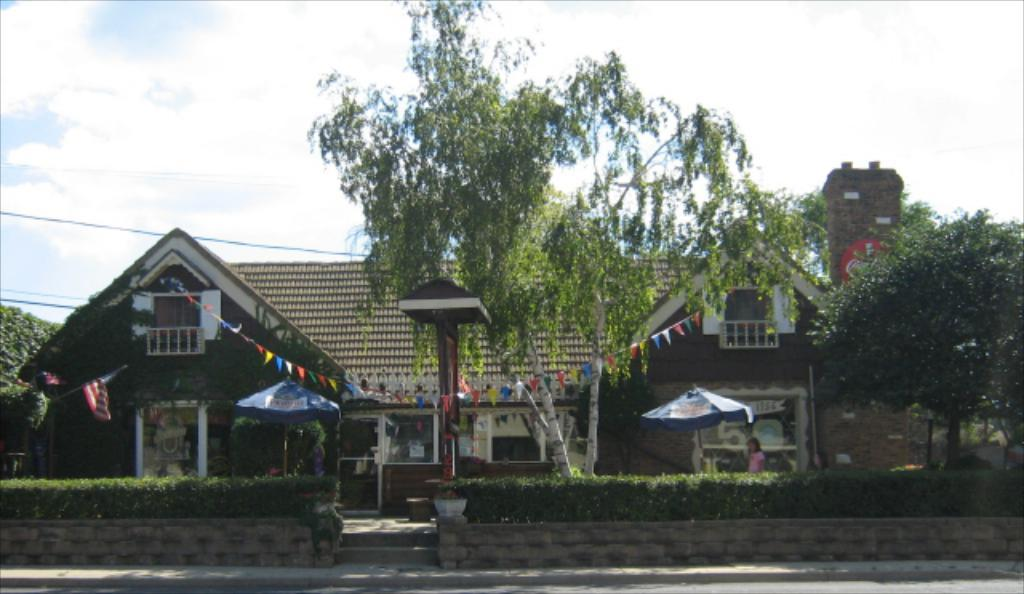What type of structure is in the picture? There is a house in the picture. What can be seen on either side of the house? There are two umbrellas on either side of the house. What is in front of the house? There are plants and trees in front of the house. Where is the chimney located in the picture? There is a chimney in the right corner of the picture. What type of gun is being used to approve the house in the picture? There is no gun or approval process depicted in the image; it simply shows a house with umbrellas, plants, trees, and a chimney. 